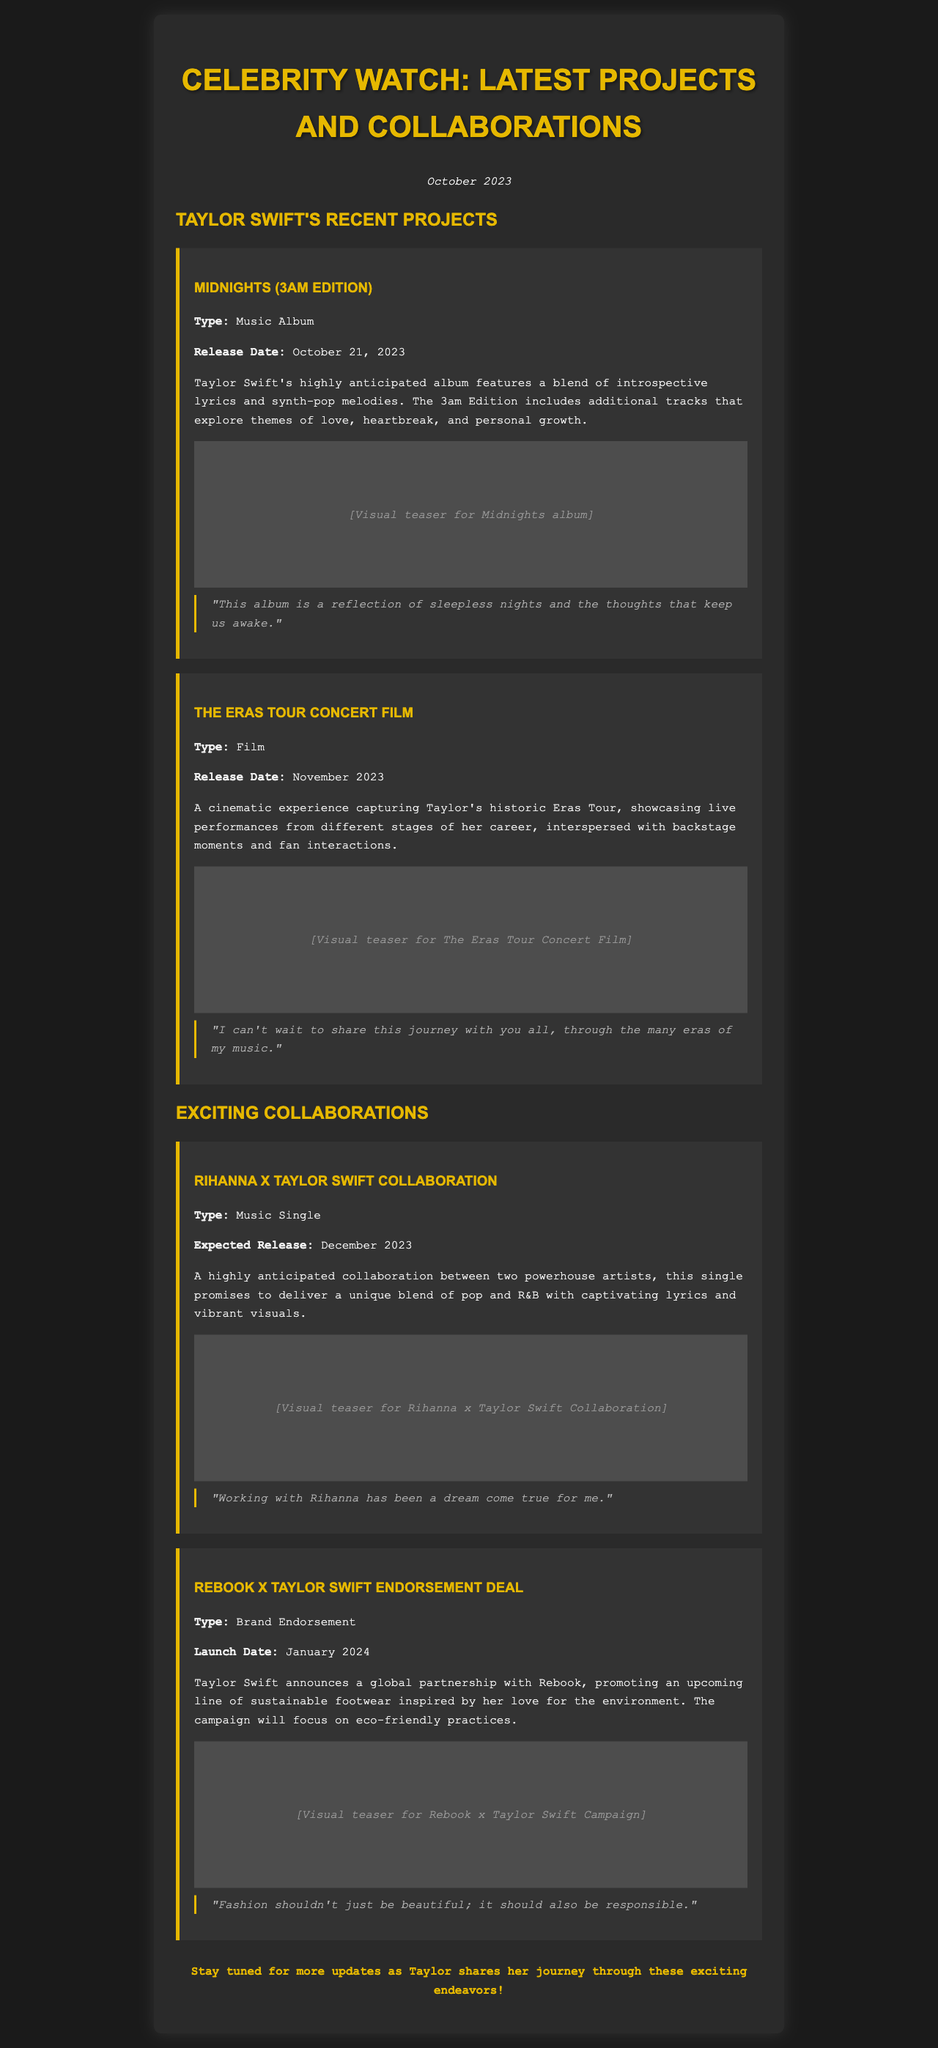What is the release date of "Midnights (3am Edition)"? The release date is mentioned in the document under the project section for "Midnights (3am Edition)," which is October 21, 2023.
Answer: October 21, 2023 What type of project is "The Eras Tour Concert Film"? The document specifies that "The Eras Tour Concert Film" is classified as a film under the project section.
Answer: Film When is the expected release date of the Rihanna x Taylor Swift collaboration? The expected release date is found in the collaboration section of the document, stating December 2023.
Answer: December 2023 What sustainable brand is Taylor collaborating with for an endorsement deal? The document clearly states that Taylor Swift is partnering with Rebook for the endorsement deal.
Answer: Rebook What genre does the Rihanna x Taylor Swift collaboration promise to deliver? The document describes the genre as a unique blend of pop and R&B for the music single collaboration.
Answer: Pop and R&B How many projects are mentioned in total in the document? The document lists two projects under 'Recent Projects' and two collaborations under 'Exciting Collaborations,' totaling four.
Answer: Four What is the theme of the "Midnights" album according to the document? The document mentions that the "Midnights" album explores themes of love, heartbreak, and personal growth.
Answer: Love, heartbreak, and personal growth What type of experience does "The Eras Tour Concert Film" aim to provide? The document states that it aims to provide a cinematic experience capturing live performances and backstage moments.
Answer: Cinematic experience What will the Rebook x Taylor Swift campaign focus on? The document indicates that the campaign will focus on eco-friendly practices inspired by Taylor's love for the environment.
Answer: Eco-friendly practices 